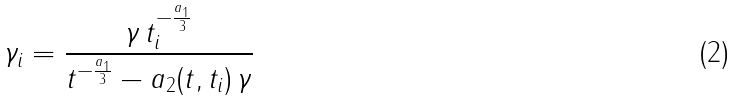Convert formula to latex. <formula><loc_0><loc_0><loc_500><loc_500>\gamma _ { i } = \frac { \gamma \, t _ { i } ^ { - \frac { a _ { 1 } } { 3 } } } { t ^ { - \frac { a _ { 1 } } { 3 } } - a _ { 2 } ( t , t _ { i } ) \, \gamma }</formula> 